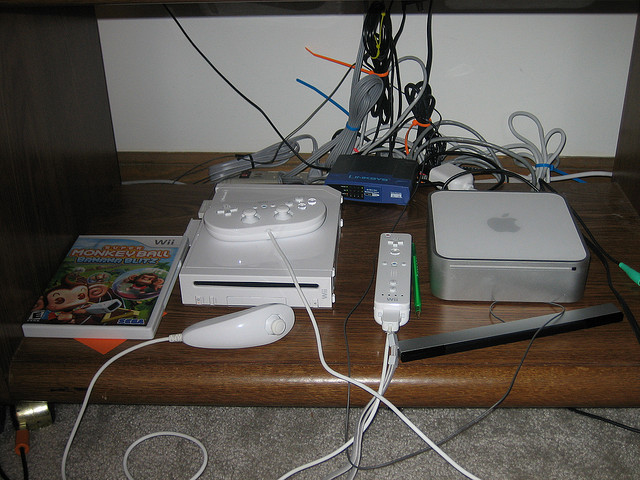Identify the text contained in this image. Wii MONKEY BALL 